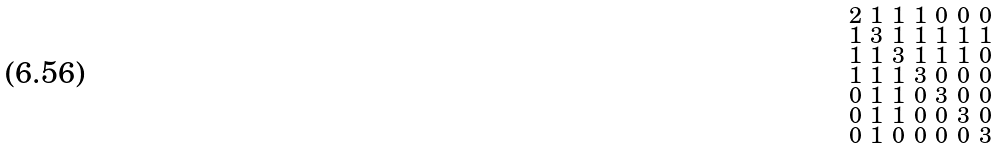Convert formula to latex. <formula><loc_0><loc_0><loc_500><loc_500>\begin{smallmatrix} 2 & 1 & 1 & 1 & 0 & 0 & 0 \\ 1 & 3 & 1 & 1 & 1 & 1 & 1 \\ 1 & 1 & 3 & 1 & 1 & 1 & 0 \\ 1 & 1 & 1 & 3 & 0 & 0 & 0 \\ 0 & 1 & 1 & 0 & 3 & 0 & 0 \\ 0 & 1 & 1 & 0 & 0 & 3 & 0 \\ 0 & 1 & 0 & 0 & 0 & 0 & 3 \end{smallmatrix}</formula> 